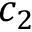<formula> <loc_0><loc_0><loc_500><loc_500>c _ { 2 }</formula> 